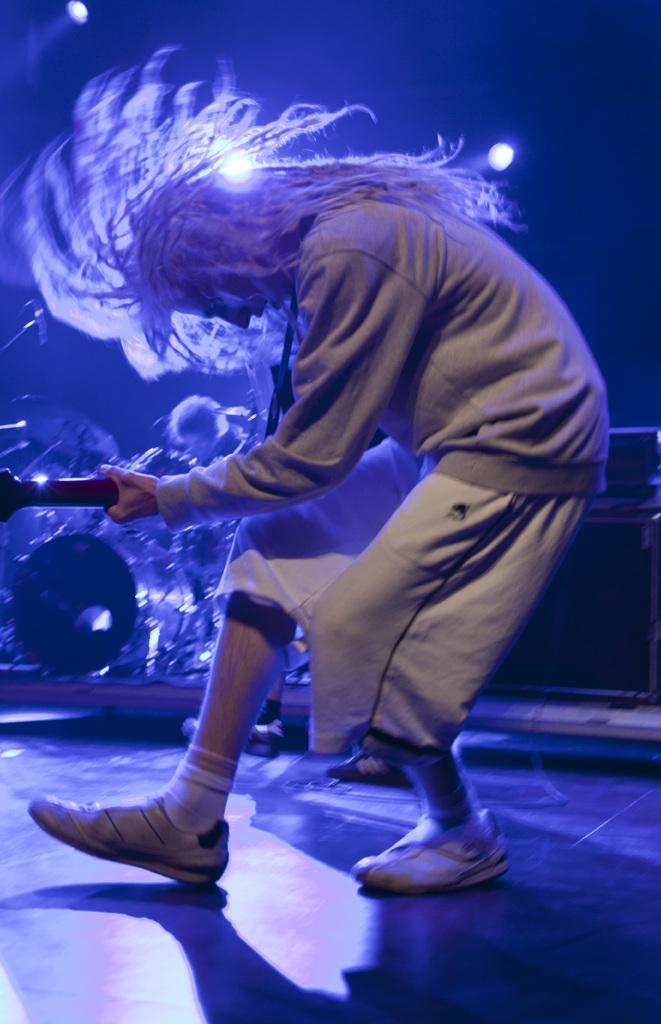What is the main activity being performed in the image? There is a person playing guitar in the image. How would you describe the lighting conditions in the image? The background of the image is dark. Can you identify any other people in the image? Yes, there is a person visible in the background of the image. What else can be seen in the background of the image? A musical instrument and a device are present in the background of the image, along with lights. What type of circle is being drawn by the brain in the image? There is no circle or brain present in the image; it features a person playing guitar and other elements in the background. 